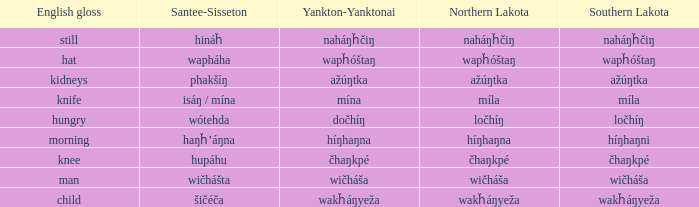Name the southern lakota for híŋhaŋna Híŋhaŋni. 